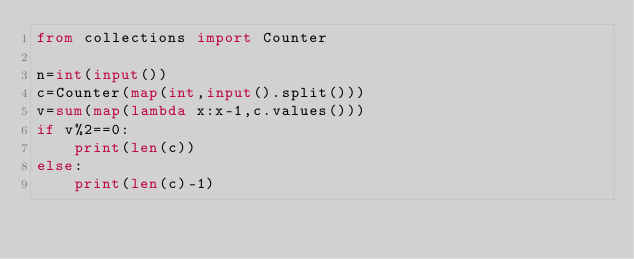<code> <loc_0><loc_0><loc_500><loc_500><_Python_>from collections import Counter

n=int(input())
c=Counter(map(int,input().split()))
v=sum(map(lambda x:x-1,c.values()))
if v%2==0:
    print(len(c))
else:
    print(len(c)-1)</code> 